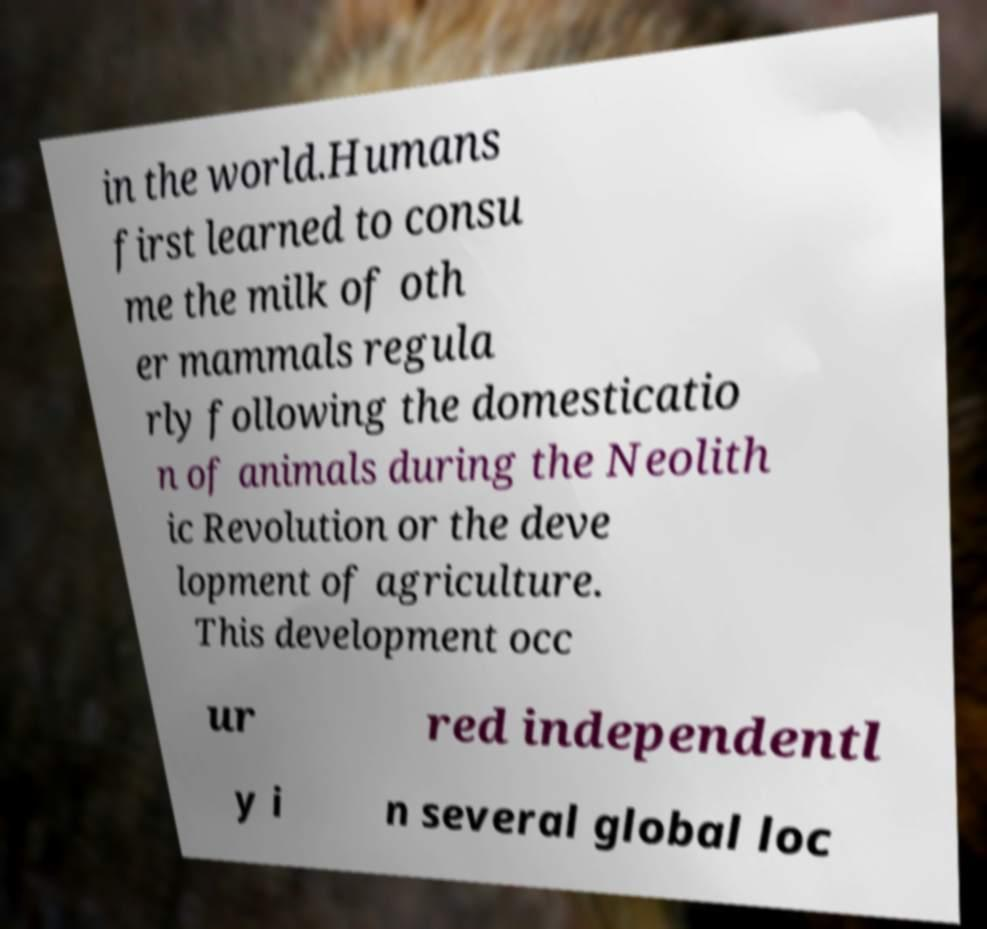Can you accurately transcribe the text from the provided image for me? in the world.Humans first learned to consu me the milk of oth er mammals regula rly following the domesticatio n of animals during the Neolith ic Revolution or the deve lopment of agriculture. This development occ ur red independentl y i n several global loc 